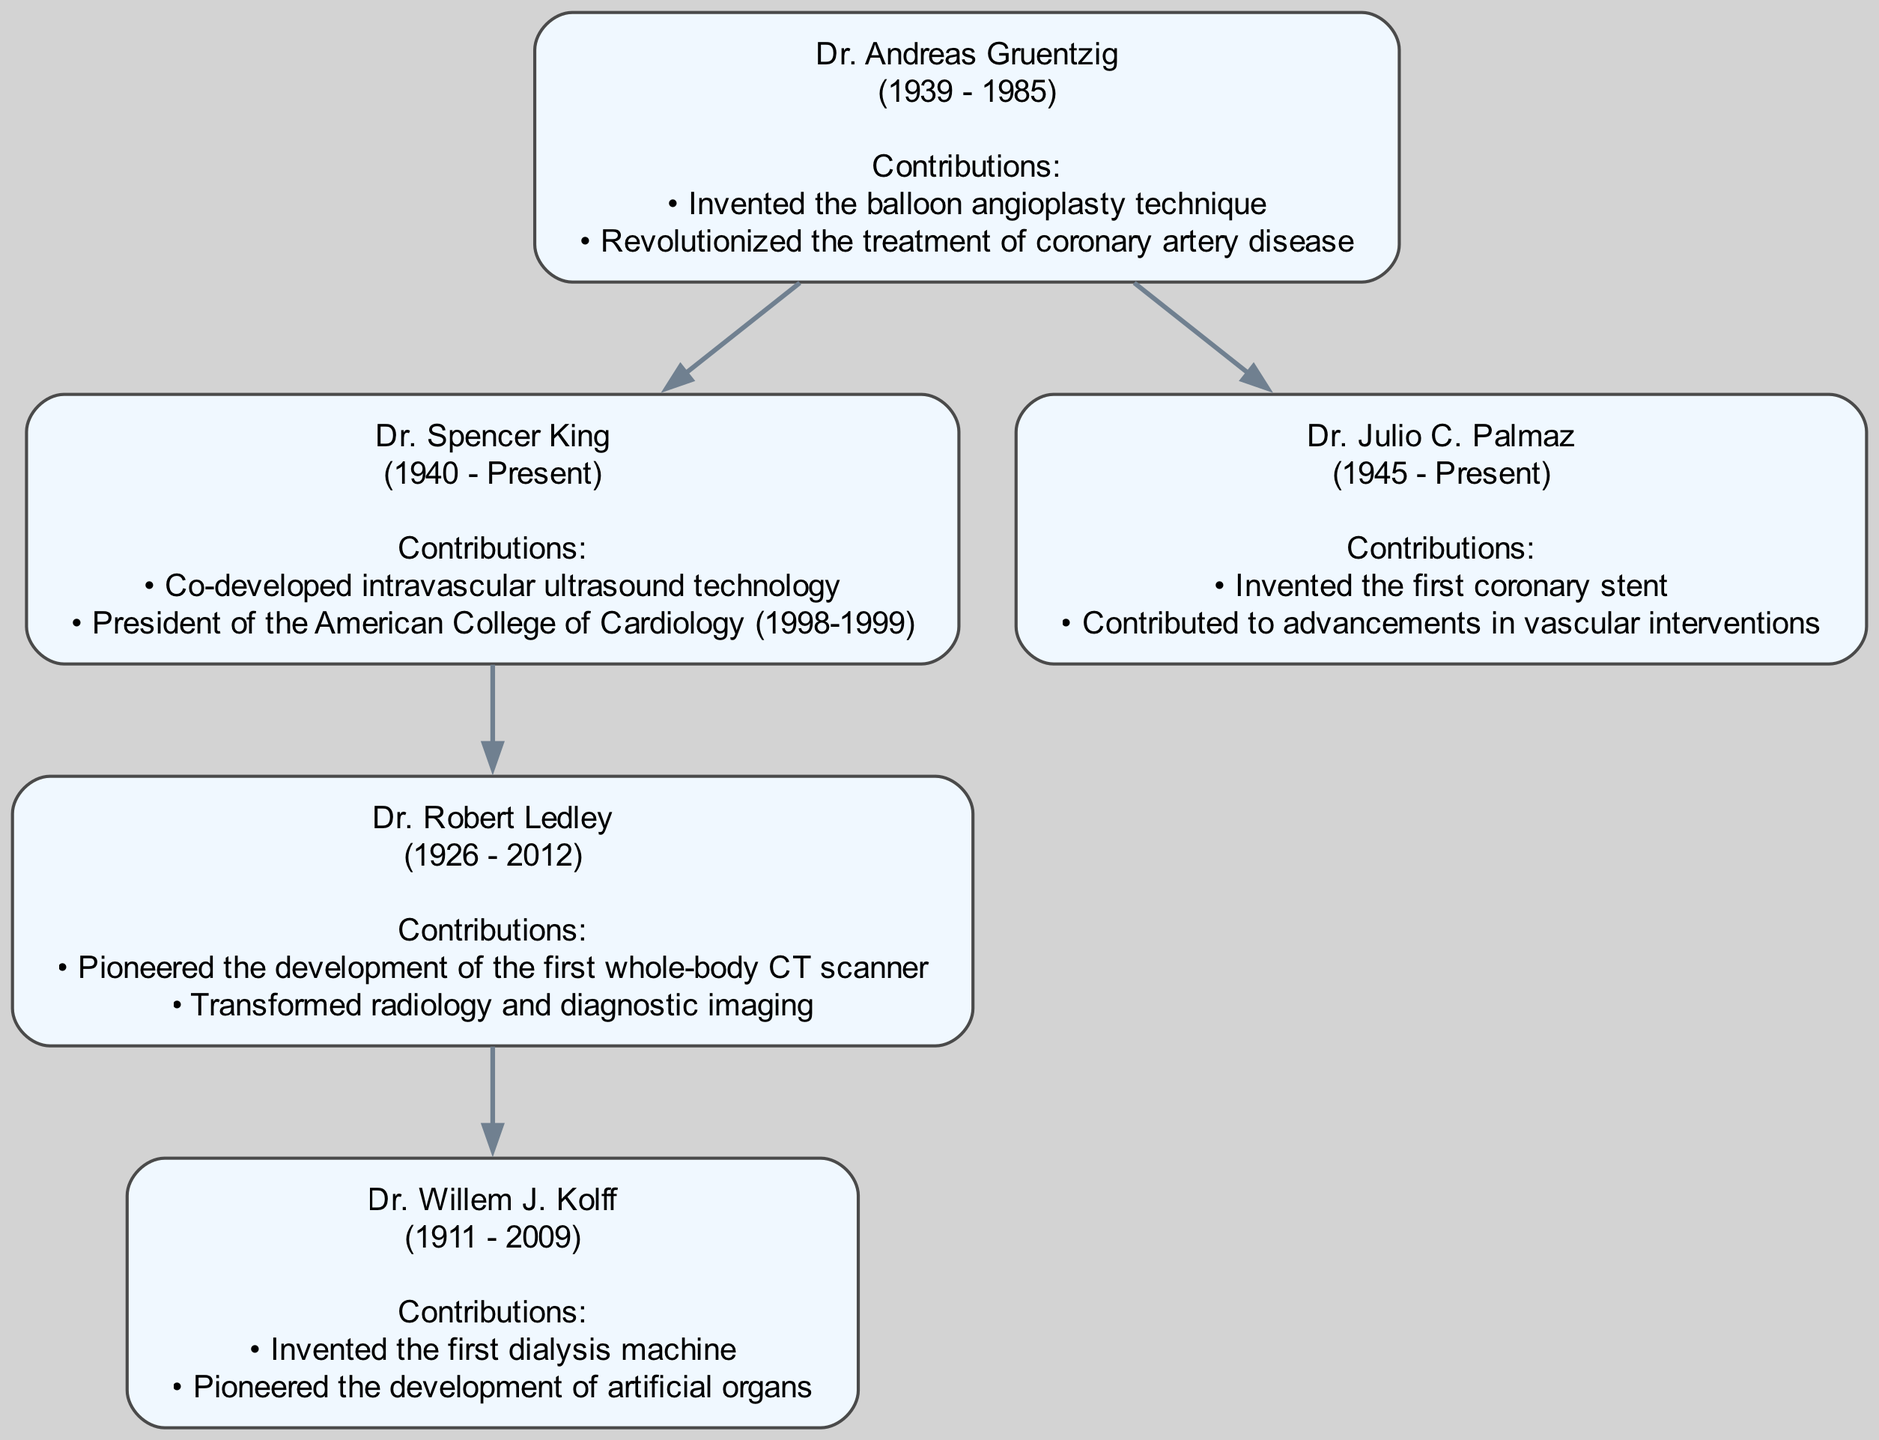What year was Dr. Andreas Gruentzig born? To find the birth year of Dr. Andreas Gruentzig, I look directly at his node in the diagram. The information provided indicates that he was born in 1939.
Answer: 1939 Who is the parent of Dr. Robert Ledley? I examine Dr. Robert Ledley's node and look for the 'parent' relationship indicated in the diagram. It shows that his parent is Dr. Spencer King.
Answer: Dr. Spencer King How many children did Dr. Andreas Gruentzig have? To determine the number of children Dr. Andreas Gruentzig had, I look at his node and count the entries in the 'children' list. It shows he has two children: Dr. Spencer King and Dr. Julio C. Palmaz.
Answer: 2 What major medical contribution is associated with Dr. Julio C. Palmaz? I refer to Dr. Julio C. Palmaz's node, which lists his contributions. It indicates he is known for inventing the first coronary stent.
Answer: Invented the first coronary stent Which person in the tree was involved in the development of the first whole-body CT scanner? I look for the individual associated with the contribution regarding the first whole-body CT scanner. The node for Dr. Robert Ledley mentions that he pioneered its development.
Answer: Dr. Robert Ledley Which person is a child of Dr. Spencer King? I check Dr. Spencer King's node for details on his children. The diagram indicates that he has one child, Dr. Robert Ledley.
Answer: Dr. Robert Ledley What years encompass the life of Dr. Willem J. Kolff? I look at Dr. Willem J. Kolff's node to find the birth and death years provided. It states he was born in 1911 and passed away in 2009.
Answer: 1911 - 2009 Who contributed to advancements in vascular interventions? Identifying the contributions listed in the diagram, I find that Dr. Julio C. Palmaz is noted for contributing to advancements in vascular interventions.
Answer: Dr. Julio C. Palmaz How many nodes are in the family tree? To answer how many nodes are in the family tree, I count each distinct person represented in the diagram. There are five individuals in total.
Answer: 5 